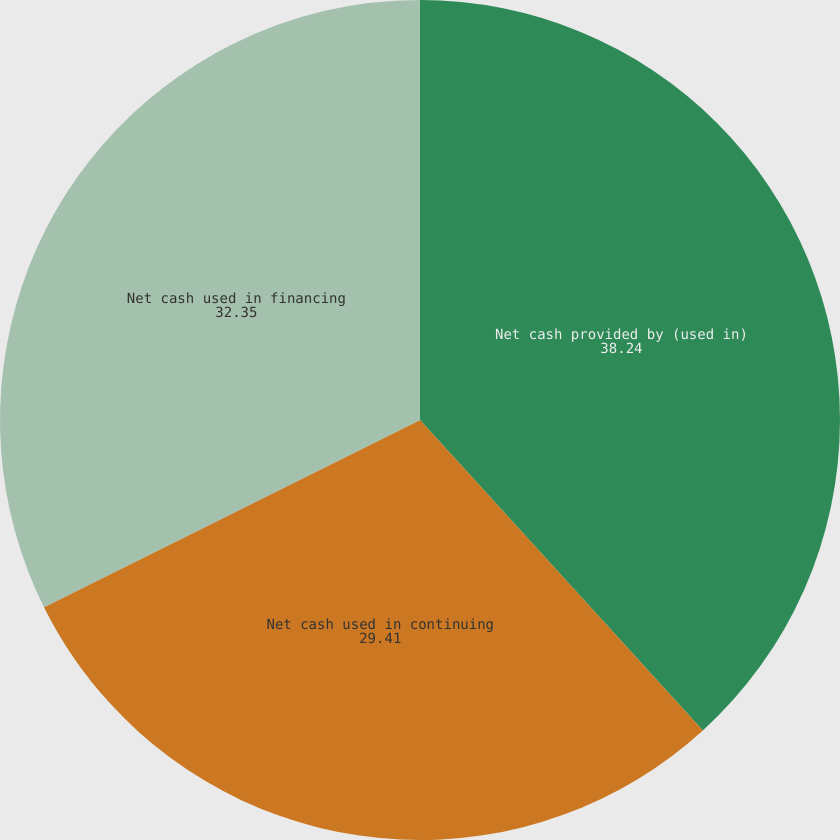<chart> <loc_0><loc_0><loc_500><loc_500><pie_chart><fcel>Net cash provided by (used in)<fcel>Net cash used in continuing<fcel>Net cash used in financing<nl><fcel>38.24%<fcel>29.41%<fcel>32.35%<nl></chart> 